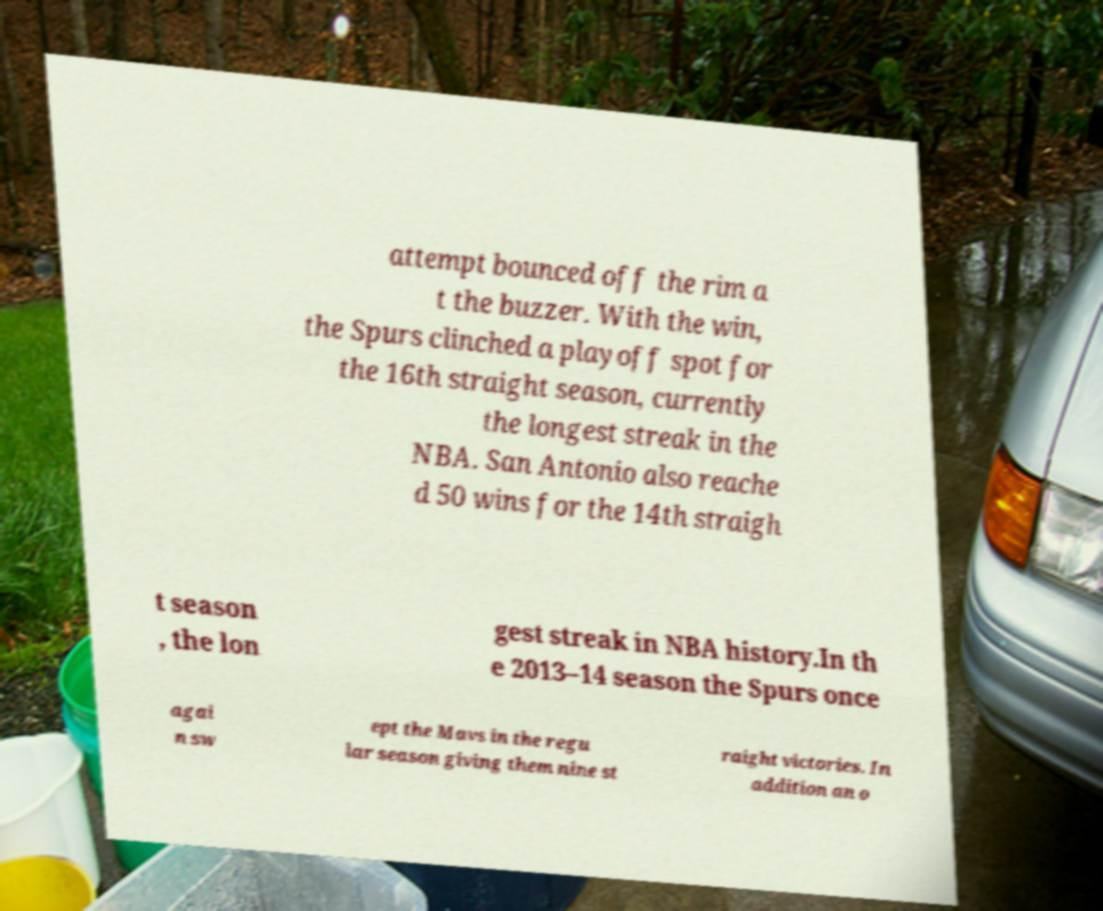For documentation purposes, I need the text within this image transcribed. Could you provide that? attempt bounced off the rim a t the buzzer. With the win, the Spurs clinched a playoff spot for the 16th straight season, currently the longest streak in the NBA. San Antonio also reache d 50 wins for the 14th straigh t season , the lon gest streak in NBA history.In th e 2013–14 season the Spurs once agai n sw ept the Mavs in the regu lar season giving them nine st raight victories. In addition an o 